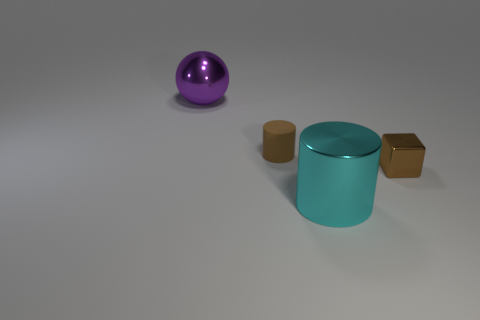Can you describe the shapes and colors present in the image? Certainly! The image showcases a variety of shapes and colors. There's a large purple metallic ball, a teal cylindrical object, and two blocks that appear metallic with one being red and the other tan or beige. The background is a neutral grey, creating a contrast that highlights the objects.  How do the objects seem to be arranged in the space? The objects are dispersed with ample space between them, set against a flat surface. The arrangement seems intentional, as there's a balance achieved through the positioning, with the purple ball and the red block sharing the space harmoniously. 